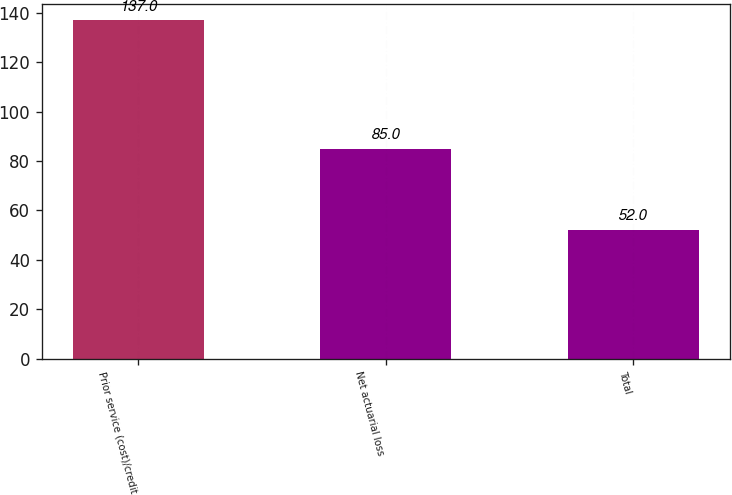Convert chart. <chart><loc_0><loc_0><loc_500><loc_500><bar_chart><fcel>Prior service (cost)/credit<fcel>Net actuarial loss<fcel>Total<nl><fcel>137<fcel>85<fcel>52<nl></chart> 